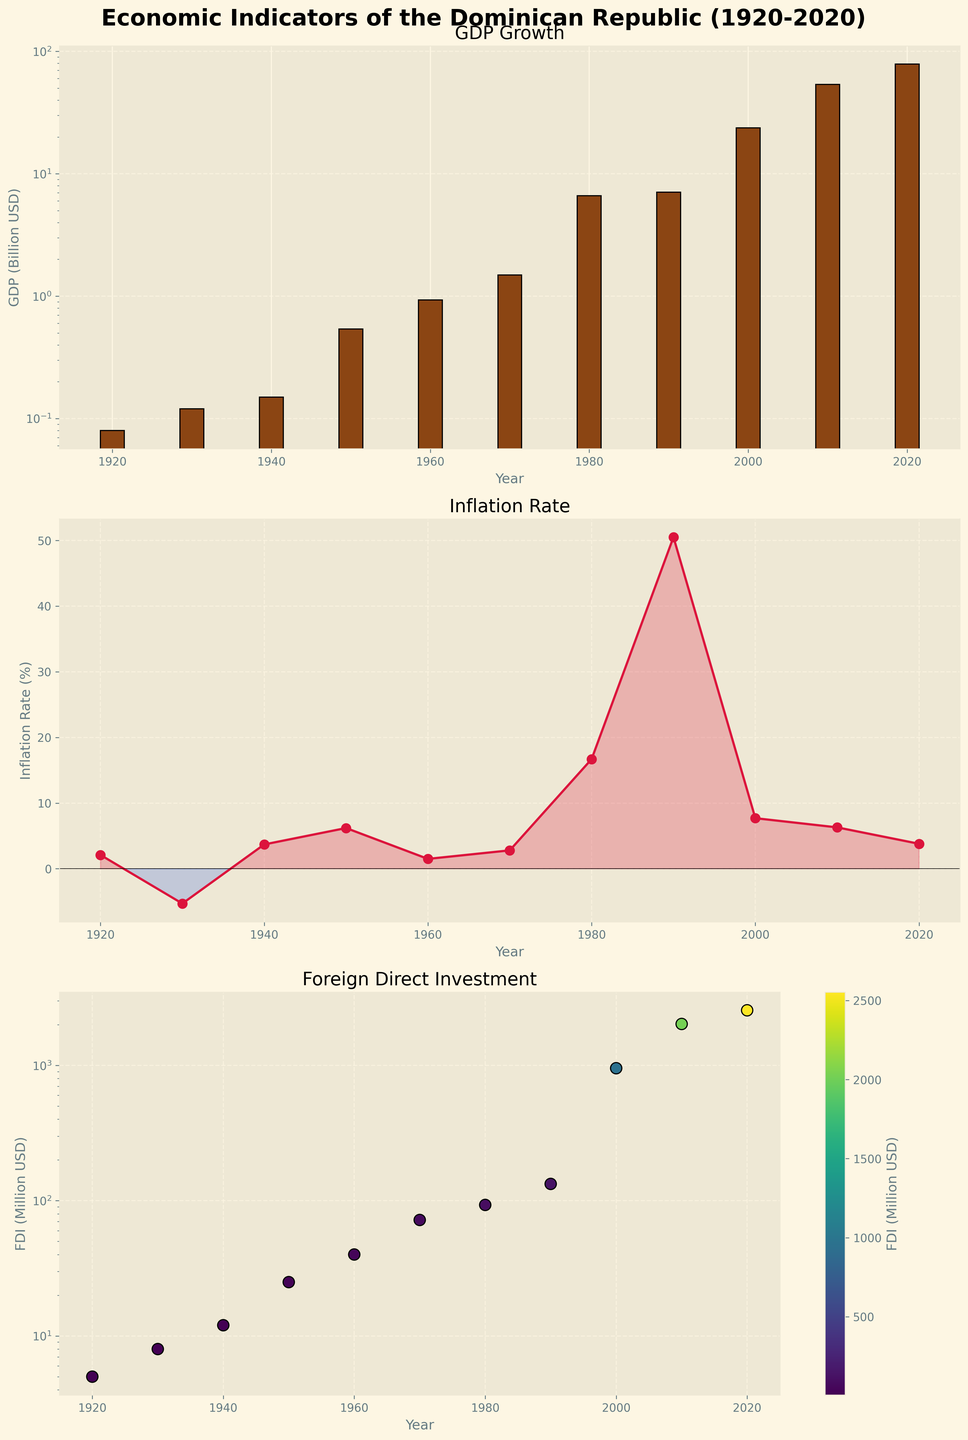What is the title of the figure? The title is found at the top of the figure. It reads "Economic Indicators of the Dominican Republic (1920-2020)".
Answer: Economic Indicators of the Dominican Republic (1920-2020) How many subplots are present in the figure? There are three distinct subplot panels displayed vertically within the figure, each with its own title.
Answer: Three What are the colors used in the GDP bar chart? The GDP bar chart uses brownish bars with black edges and a yellowish background due to the 'Solarize_Light2' style.
Answer: Brown and black Which year had the highest inflation rate, and what was the rate? Looking at the inflation rate line plot, we find the highest data point, which is labeled for the year 1990 with an inflation rate of 50.5%.
Answer: 1990, 50.5% Comparing 1940 and 1980, which year had higher GDP and by how much? From the GDP bar chart, in 1940, the GDP was 0.15 billion USD, and in 1980, it was 6.63 billion USD. The difference is 6.63 - 0.15 = 6.48 billion USD.
Answer: 1980 by 6.48 billion USD What is the trend of Foreign Direct Investment (FDI) from 1920 to 2020? Observing the FDI scatter plot, the general trend is a steady increase with noticeable increments in more recent decades.
Answer: Increasing trend In which decade did the Dominican Republic experience the first negative inflation rate according to the plot? Observing the inflation line plot, we notice the inflation rate drops below zero in 1930.
Answer: 1930s What is the relationship between inflation rates and GDP during the 1990s? In the 1990s, the inflation rate spiked significantly, while the GDP showed moderate growth compared to other decades, indicating potential economic instability.
Answer: High inflation, moderate GDP growth For which year is the foreign direct investment marked with the largest dot, and what is its value? The largest dot in the FDI scatter plot corresponds to the year 2020, with a value of 2554 million USD.
Answer: 2020, 2554 million USD 